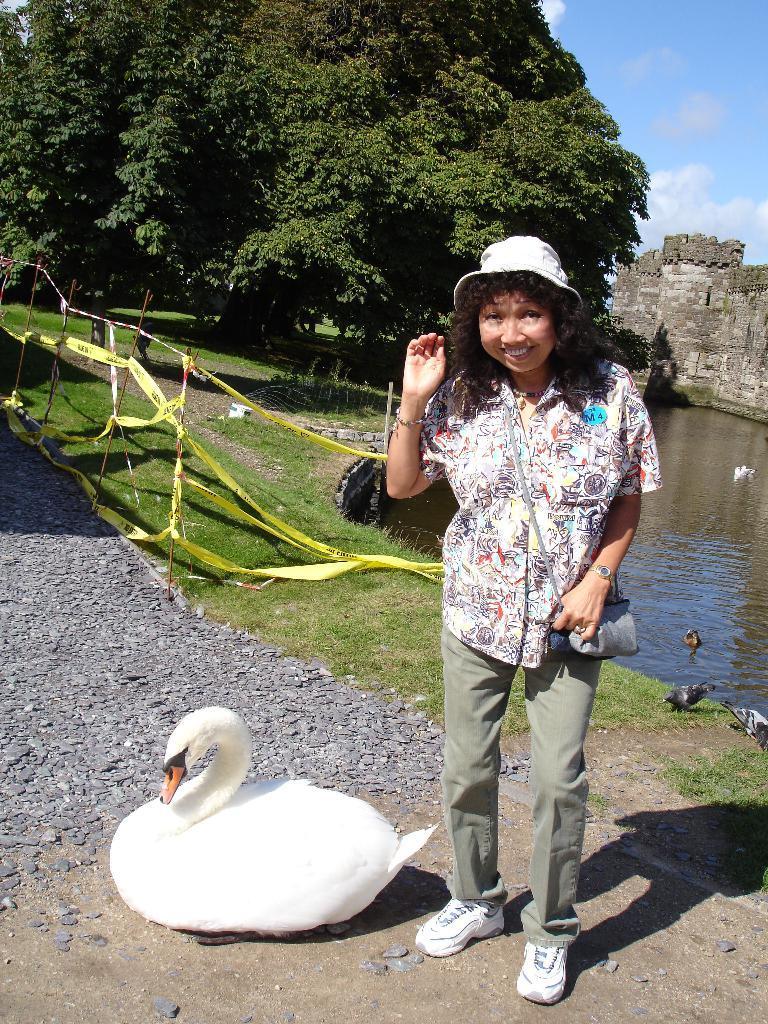Please provide a concise description of this image. In this image we can see a swan on the ground. We can also see a woman standing beside it. On the backside we can see the concrete floor, a fence tied with some ribbons, grass, a water body, a group of trees, a building and the sky which looks cloudy. 